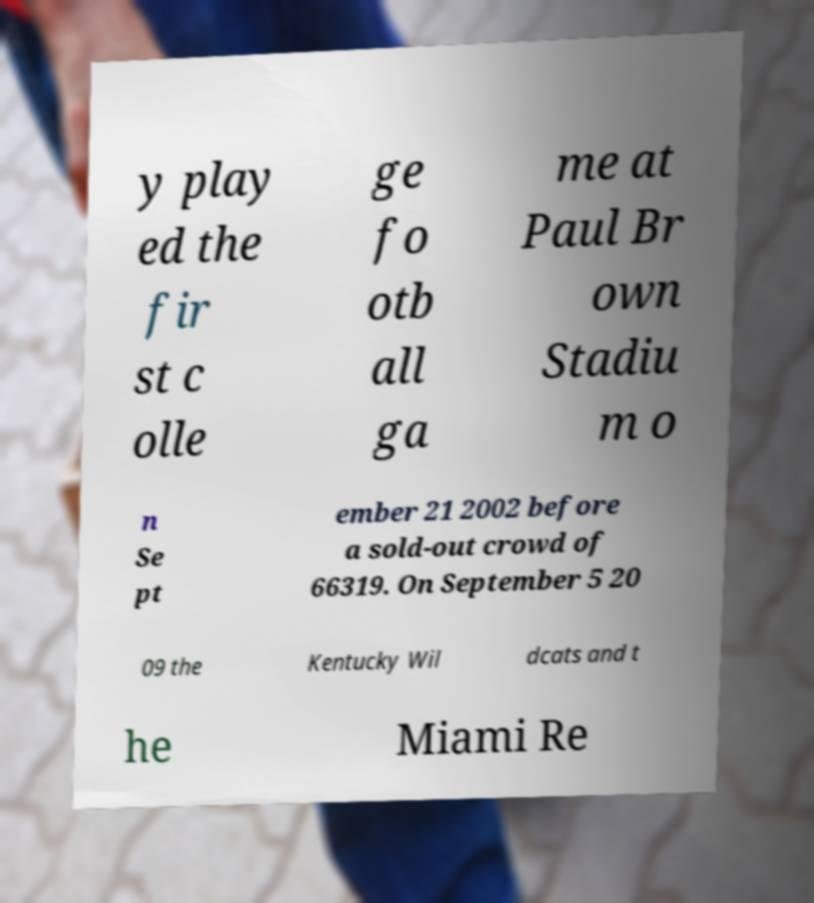There's text embedded in this image that I need extracted. Can you transcribe it verbatim? y play ed the fir st c olle ge fo otb all ga me at Paul Br own Stadiu m o n Se pt ember 21 2002 before a sold-out crowd of 66319. On September 5 20 09 the Kentucky Wil dcats and t he Miami Re 